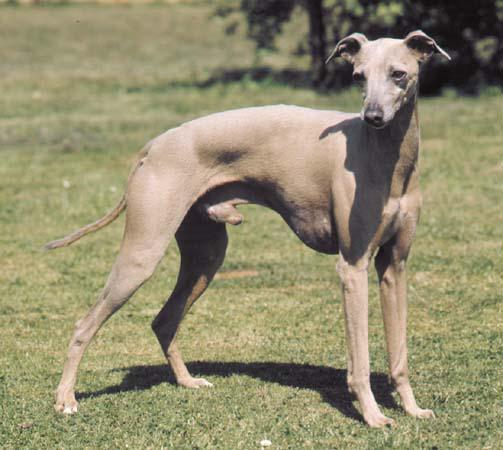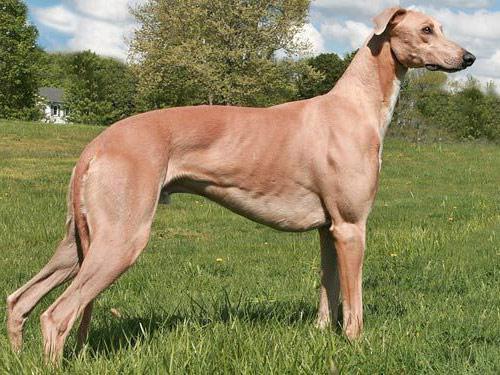The first image is the image on the left, the second image is the image on the right. Given the left and right images, does the statement "The right image shows a hound standing on thick green grass." hold true? Answer yes or no. Yes. 